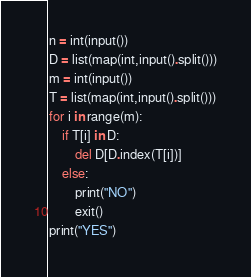Convert code to text. <code><loc_0><loc_0><loc_500><loc_500><_Python_>n = int(input())
D = list(map(int,input().split()))
m = int(input())
T = list(map(int,input().split()))
for i in range(m):
    if T[i] in D:
        del D[D.index(T[i])]
    else:
        print("NO")
        exit()
print("YES")</code> 